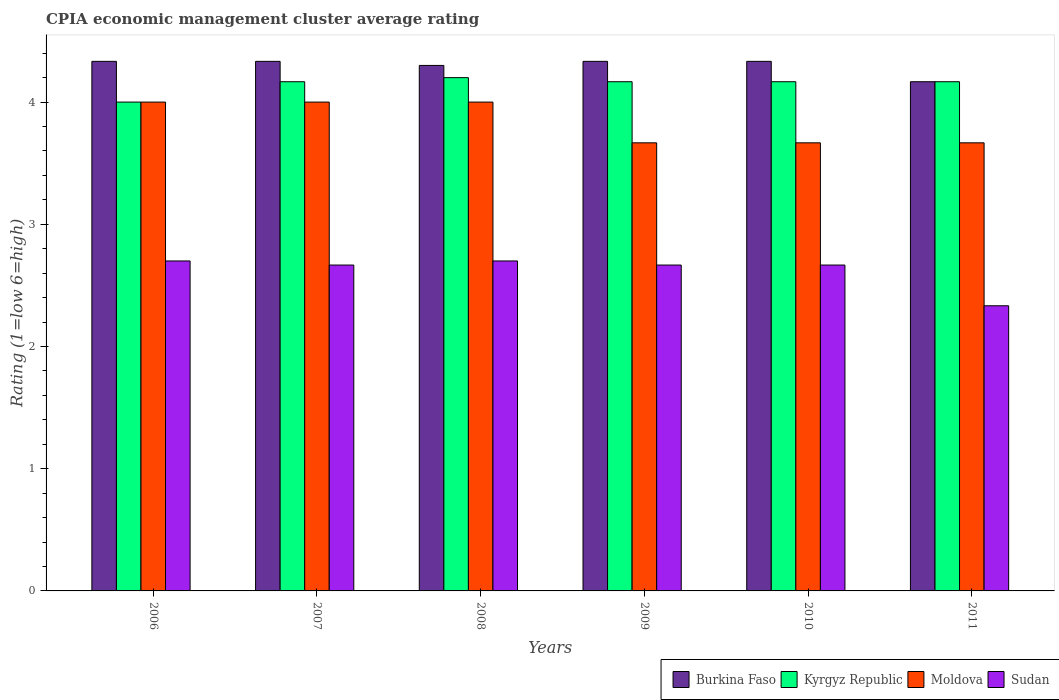How many different coloured bars are there?
Offer a terse response. 4. How many groups of bars are there?
Make the answer very short. 6. What is the label of the 3rd group of bars from the left?
Your answer should be very brief. 2008. Across all years, what is the maximum CPIA rating in Kyrgyz Republic?
Provide a short and direct response. 4.2. In which year was the CPIA rating in Kyrgyz Republic maximum?
Provide a short and direct response. 2008. In which year was the CPIA rating in Sudan minimum?
Keep it short and to the point. 2011. What is the total CPIA rating in Burkina Faso in the graph?
Your answer should be very brief. 25.8. What is the difference between the CPIA rating in Burkina Faso in 2008 and that in 2011?
Ensure brevity in your answer.  0.13. What is the difference between the CPIA rating in Burkina Faso in 2010 and the CPIA rating in Sudan in 2006?
Make the answer very short. 1.63. What is the average CPIA rating in Moldova per year?
Make the answer very short. 3.83. In the year 2006, what is the difference between the CPIA rating in Moldova and CPIA rating in Sudan?
Provide a succinct answer. 1.3. Is the CPIA rating in Sudan in 2006 less than that in 2007?
Ensure brevity in your answer.  No. What is the difference between the highest and the lowest CPIA rating in Burkina Faso?
Give a very brief answer. 0.17. Is it the case that in every year, the sum of the CPIA rating in Moldova and CPIA rating in Sudan is greater than the sum of CPIA rating in Kyrgyz Republic and CPIA rating in Burkina Faso?
Provide a short and direct response. Yes. What does the 2nd bar from the left in 2009 represents?
Provide a succinct answer. Kyrgyz Republic. What does the 3rd bar from the right in 2010 represents?
Provide a succinct answer. Kyrgyz Republic. Are all the bars in the graph horizontal?
Your answer should be compact. No. How many years are there in the graph?
Your response must be concise. 6. What is the difference between two consecutive major ticks on the Y-axis?
Your answer should be compact. 1. How many legend labels are there?
Your response must be concise. 4. How are the legend labels stacked?
Offer a very short reply. Horizontal. What is the title of the graph?
Your answer should be very brief. CPIA economic management cluster average rating. What is the label or title of the X-axis?
Ensure brevity in your answer.  Years. What is the Rating (1=low 6=high) of Burkina Faso in 2006?
Ensure brevity in your answer.  4.33. What is the Rating (1=low 6=high) of Kyrgyz Republic in 2006?
Offer a very short reply. 4. What is the Rating (1=low 6=high) in Moldova in 2006?
Make the answer very short. 4. What is the Rating (1=low 6=high) in Burkina Faso in 2007?
Your answer should be very brief. 4.33. What is the Rating (1=low 6=high) of Kyrgyz Republic in 2007?
Your response must be concise. 4.17. What is the Rating (1=low 6=high) in Moldova in 2007?
Provide a succinct answer. 4. What is the Rating (1=low 6=high) in Sudan in 2007?
Make the answer very short. 2.67. What is the Rating (1=low 6=high) in Kyrgyz Republic in 2008?
Give a very brief answer. 4.2. What is the Rating (1=low 6=high) of Burkina Faso in 2009?
Give a very brief answer. 4.33. What is the Rating (1=low 6=high) of Kyrgyz Republic in 2009?
Keep it short and to the point. 4.17. What is the Rating (1=low 6=high) in Moldova in 2009?
Provide a short and direct response. 3.67. What is the Rating (1=low 6=high) in Sudan in 2009?
Your answer should be very brief. 2.67. What is the Rating (1=low 6=high) in Burkina Faso in 2010?
Provide a short and direct response. 4.33. What is the Rating (1=low 6=high) of Kyrgyz Republic in 2010?
Your answer should be very brief. 4.17. What is the Rating (1=low 6=high) in Moldova in 2010?
Offer a very short reply. 3.67. What is the Rating (1=low 6=high) in Sudan in 2010?
Ensure brevity in your answer.  2.67. What is the Rating (1=low 6=high) in Burkina Faso in 2011?
Your response must be concise. 4.17. What is the Rating (1=low 6=high) in Kyrgyz Republic in 2011?
Your response must be concise. 4.17. What is the Rating (1=low 6=high) in Moldova in 2011?
Offer a terse response. 3.67. What is the Rating (1=low 6=high) of Sudan in 2011?
Make the answer very short. 2.33. Across all years, what is the maximum Rating (1=low 6=high) of Burkina Faso?
Your response must be concise. 4.33. Across all years, what is the maximum Rating (1=low 6=high) of Kyrgyz Republic?
Make the answer very short. 4.2. Across all years, what is the maximum Rating (1=low 6=high) of Moldova?
Ensure brevity in your answer.  4. Across all years, what is the maximum Rating (1=low 6=high) in Sudan?
Your answer should be compact. 2.7. Across all years, what is the minimum Rating (1=low 6=high) of Burkina Faso?
Give a very brief answer. 4.17. Across all years, what is the minimum Rating (1=low 6=high) in Moldova?
Make the answer very short. 3.67. Across all years, what is the minimum Rating (1=low 6=high) of Sudan?
Keep it short and to the point. 2.33. What is the total Rating (1=low 6=high) in Burkina Faso in the graph?
Offer a terse response. 25.8. What is the total Rating (1=low 6=high) in Kyrgyz Republic in the graph?
Your response must be concise. 24.87. What is the total Rating (1=low 6=high) in Sudan in the graph?
Your response must be concise. 15.73. What is the difference between the Rating (1=low 6=high) in Burkina Faso in 2006 and that in 2007?
Your answer should be compact. 0. What is the difference between the Rating (1=low 6=high) of Burkina Faso in 2006 and that in 2008?
Make the answer very short. 0.03. What is the difference between the Rating (1=low 6=high) of Kyrgyz Republic in 2006 and that in 2008?
Make the answer very short. -0.2. What is the difference between the Rating (1=low 6=high) of Moldova in 2006 and that in 2008?
Provide a short and direct response. 0. What is the difference between the Rating (1=low 6=high) of Kyrgyz Republic in 2006 and that in 2009?
Your response must be concise. -0.17. What is the difference between the Rating (1=low 6=high) in Moldova in 2006 and that in 2009?
Provide a succinct answer. 0.33. What is the difference between the Rating (1=low 6=high) in Moldova in 2006 and that in 2010?
Provide a short and direct response. 0.33. What is the difference between the Rating (1=low 6=high) of Sudan in 2006 and that in 2010?
Offer a very short reply. 0.03. What is the difference between the Rating (1=low 6=high) of Burkina Faso in 2006 and that in 2011?
Make the answer very short. 0.17. What is the difference between the Rating (1=low 6=high) in Sudan in 2006 and that in 2011?
Your response must be concise. 0.37. What is the difference between the Rating (1=low 6=high) in Kyrgyz Republic in 2007 and that in 2008?
Keep it short and to the point. -0.03. What is the difference between the Rating (1=low 6=high) in Moldova in 2007 and that in 2008?
Your answer should be very brief. 0. What is the difference between the Rating (1=low 6=high) of Sudan in 2007 and that in 2008?
Keep it short and to the point. -0.03. What is the difference between the Rating (1=low 6=high) of Burkina Faso in 2007 and that in 2009?
Give a very brief answer. 0. What is the difference between the Rating (1=low 6=high) of Moldova in 2007 and that in 2009?
Keep it short and to the point. 0.33. What is the difference between the Rating (1=low 6=high) in Sudan in 2007 and that in 2009?
Your answer should be very brief. 0. What is the difference between the Rating (1=low 6=high) of Burkina Faso in 2007 and that in 2011?
Provide a short and direct response. 0.17. What is the difference between the Rating (1=low 6=high) in Sudan in 2007 and that in 2011?
Offer a terse response. 0.33. What is the difference between the Rating (1=low 6=high) in Burkina Faso in 2008 and that in 2009?
Provide a succinct answer. -0.03. What is the difference between the Rating (1=low 6=high) in Moldova in 2008 and that in 2009?
Your answer should be very brief. 0.33. What is the difference between the Rating (1=low 6=high) of Burkina Faso in 2008 and that in 2010?
Offer a terse response. -0.03. What is the difference between the Rating (1=low 6=high) of Burkina Faso in 2008 and that in 2011?
Give a very brief answer. 0.13. What is the difference between the Rating (1=low 6=high) of Moldova in 2008 and that in 2011?
Your response must be concise. 0.33. What is the difference between the Rating (1=low 6=high) in Sudan in 2008 and that in 2011?
Offer a terse response. 0.37. What is the difference between the Rating (1=low 6=high) in Burkina Faso in 2009 and that in 2010?
Ensure brevity in your answer.  0. What is the difference between the Rating (1=low 6=high) in Burkina Faso in 2010 and that in 2011?
Your answer should be very brief. 0.17. What is the difference between the Rating (1=low 6=high) in Kyrgyz Republic in 2010 and that in 2011?
Provide a short and direct response. 0. What is the difference between the Rating (1=low 6=high) in Moldova in 2010 and that in 2011?
Give a very brief answer. 0. What is the difference between the Rating (1=low 6=high) of Sudan in 2010 and that in 2011?
Offer a terse response. 0.33. What is the difference between the Rating (1=low 6=high) of Burkina Faso in 2006 and the Rating (1=low 6=high) of Kyrgyz Republic in 2007?
Offer a very short reply. 0.17. What is the difference between the Rating (1=low 6=high) of Burkina Faso in 2006 and the Rating (1=low 6=high) of Sudan in 2007?
Offer a terse response. 1.67. What is the difference between the Rating (1=low 6=high) in Kyrgyz Republic in 2006 and the Rating (1=low 6=high) in Sudan in 2007?
Ensure brevity in your answer.  1.33. What is the difference between the Rating (1=low 6=high) of Moldova in 2006 and the Rating (1=low 6=high) of Sudan in 2007?
Your answer should be compact. 1.33. What is the difference between the Rating (1=low 6=high) in Burkina Faso in 2006 and the Rating (1=low 6=high) in Kyrgyz Republic in 2008?
Your response must be concise. 0.13. What is the difference between the Rating (1=low 6=high) of Burkina Faso in 2006 and the Rating (1=low 6=high) of Sudan in 2008?
Provide a short and direct response. 1.63. What is the difference between the Rating (1=low 6=high) of Kyrgyz Republic in 2006 and the Rating (1=low 6=high) of Moldova in 2008?
Provide a short and direct response. 0. What is the difference between the Rating (1=low 6=high) in Kyrgyz Republic in 2006 and the Rating (1=low 6=high) in Sudan in 2008?
Offer a terse response. 1.3. What is the difference between the Rating (1=low 6=high) of Moldova in 2006 and the Rating (1=low 6=high) of Sudan in 2008?
Offer a very short reply. 1.3. What is the difference between the Rating (1=low 6=high) of Burkina Faso in 2006 and the Rating (1=low 6=high) of Kyrgyz Republic in 2009?
Your answer should be very brief. 0.17. What is the difference between the Rating (1=low 6=high) in Burkina Faso in 2006 and the Rating (1=low 6=high) in Sudan in 2009?
Your answer should be very brief. 1.67. What is the difference between the Rating (1=low 6=high) of Kyrgyz Republic in 2006 and the Rating (1=low 6=high) of Sudan in 2009?
Provide a short and direct response. 1.33. What is the difference between the Rating (1=low 6=high) of Kyrgyz Republic in 2006 and the Rating (1=low 6=high) of Moldova in 2010?
Provide a short and direct response. 0.33. What is the difference between the Rating (1=low 6=high) of Burkina Faso in 2006 and the Rating (1=low 6=high) of Moldova in 2011?
Ensure brevity in your answer.  0.67. What is the difference between the Rating (1=low 6=high) of Burkina Faso in 2006 and the Rating (1=low 6=high) of Sudan in 2011?
Offer a terse response. 2. What is the difference between the Rating (1=low 6=high) of Burkina Faso in 2007 and the Rating (1=low 6=high) of Kyrgyz Republic in 2008?
Offer a very short reply. 0.13. What is the difference between the Rating (1=low 6=high) in Burkina Faso in 2007 and the Rating (1=low 6=high) in Sudan in 2008?
Offer a very short reply. 1.63. What is the difference between the Rating (1=low 6=high) in Kyrgyz Republic in 2007 and the Rating (1=low 6=high) in Sudan in 2008?
Keep it short and to the point. 1.47. What is the difference between the Rating (1=low 6=high) in Burkina Faso in 2007 and the Rating (1=low 6=high) in Kyrgyz Republic in 2009?
Offer a very short reply. 0.17. What is the difference between the Rating (1=low 6=high) of Burkina Faso in 2007 and the Rating (1=low 6=high) of Sudan in 2009?
Ensure brevity in your answer.  1.67. What is the difference between the Rating (1=low 6=high) in Kyrgyz Republic in 2007 and the Rating (1=low 6=high) in Moldova in 2009?
Ensure brevity in your answer.  0.5. What is the difference between the Rating (1=low 6=high) of Kyrgyz Republic in 2007 and the Rating (1=low 6=high) of Sudan in 2009?
Give a very brief answer. 1.5. What is the difference between the Rating (1=low 6=high) in Burkina Faso in 2007 and the Rating (1=low 6=high) in Kyrgyz Republic in 2010?
Give a very brief answer. 0.17. What is the difference between the Rating (1=low 6=high) of Burkina Faso in 2007 and the Rating (1=low 6=high) of Moldova in 2010?
Offer a terse response. 0.67. What is the difference between the Rating (1=low 6=high) of Burkina Faso in 2007 and the Rating (1=low 6=high) of Sudan in 2010?
Your answer should be compact. 1.67. What is the difference between the Rating (1=low 6=high) of Kyrgyz Republic in 2007 and the Rating (1=low 6=high) of Moldova in 2010?
Ensure brevity in your answer.  0.5. What is the difference between the Rating (1=low 6=high) of Moldova in 2007 and the Rating (1=low 6=high) of Sudan in 2010?
Provide a short and direct response. 1.33. What is the difference between the Rating (1=low 6=high) in Burkina Faso in 2007 and the Rating (1=low 6=high) in Kyrgyz Republic in 2011?
Offer a very short reply. 0.17. What is the difference between the Rating (1=low 6=high) of Burkina Faso in 2007 and the Rating (1=low 6=high) of Moldova in 2011?
Offer a terse response. 0.67. What is the difference between the Rating (1=low 6=high) in Burkina Faso in 2007 and the Rating (1=low 6=high) in Sudan in 2011?
Offer a very short reply. 2. What is the difference between the Rating (1=low 6=high) of Kyrgyz Republic in 2007 and the Rating (1=low 6=high) of Moldova in 2011?
Give a very brief answer. 0.5. What is the difference between the Rating (1=low 6=high) in Kyrgyz Republic in 2007 and the Rating (1=low 6=high) in Sudan in 2011?
Your answer should be compact. 1.83. What is the difference between the Rating (1=low 6=high) of Burkina Faso in 2008 and the Rating (1=low 6=high) of Kyrgyz Republic in 2009?
Ensure brevity in your answer.  0.13. What is the difference between the Rating (1=low 6=high) of Burkina Faso in 2008 and the Rating (1=low 6=high) of Moldova in 2009?
Your response must be concise. 0.63. What is the difference between the Rating (1=low 6=high) of Burkina Faso in 2008 and the Rating (1=low 6=high) of Sudan in 2009?
Your response must be concise. 1.63. What is the difference between the Rating (1=low 6=high) of Kyrgyz Republic in 2008 and the Rating (1=low 6=high) of Moldova in 2009?
Ensure brevity in your answer.  0.53. What is the difference between the Rating (1=low 6=high) in Kyrgyz Republic in 2008 and the Rating (1=low 6=high) in Sudan in 2009?
Your answer should be very brief. 1.53. What is the difference between the Rating (1=low 6=high) in Moldova in 2008 and the Rating (1=low 6=high) in Sudan in 2009?
Ensure brevity in your answer.  1.33. What is the difference between the Rating (1=low 6=high) of Burkina Faso in 2008 and the Rating (1=low 6=high) of Kyrgyz Republic in 2010?
Your answer should be compact. 0.13. What is the difference between the Rating (1=low 6=high) of Burkina Faso in 2008 and the Rating (1=low 6=high) of Moldova in 2010?
Provide a short and direct response. 0.63. What is the difference between the Rating (1=low 6=high) in Burkina Faso in 2008 and the Rating (1=low 6=high) in Sudan in 2010?
Provide a short and direct response. 1.63. What is the difference between the Rating (1=low 6=high) of Kyrgyz Republic in 2008 and the Rating (1=low 6=high) of Moldova in 2010?
Make the answer very short. 0.53. What is the difference between the Rating (1=low 6=high) in Kyrgyz Republic in 2008 and the Rating (1=low 6=high) in Sudan in 2010?
Your response must be concise. 1.53. What is the difference between the Rating (1=low 6=high) in Moldova in 2008 and the Rating (1=low 6=high) in Sudan in 2010?
Offer a very short reply. 1.33. What is the difference between the Rating (1=low 6=high) in Burkina Faso in 2008 and the Rating (1=low 6=high) in Kyrgyz Republic in 2011?
Your answer should be very brief. 0.13. What is the difference between the Rating (1=low 6=high) of Burkina Faso in 2008 and the Rating (1=low 6=high) of Moldova in 2011?
Keep it short and to the point. 0.63. What is the difference between the Rating (1=low 6=high) of Burkina Faso in 2008 and the Rating (1=low 6=high) of Sudan in 2011?
Your answer should be very brief. 1.97. What is the difference between the Rating (1=low 6=high) in Kyrgyz Republic in 2008 and the Rating (1=low 6=high) in Moldova in 2011?
Your response must be concise. 0.53. What is the difference between the Rating (1=low 6=high) in Kyrgyz Republic in 2008 and the Rating (1=low 6=high) in Sudan in 2011?
Ensure brevity in your answer.  1.87. What is the difference between the Rating (1=low 6=high) in Burkina Faso in 2009 and the Rating (1=low 6=high) in Sudan in 2010?
Keep it short and to the point. 1.67. What is the difference between the Rating (1=low 6=high) of Kyrgyz Republic in 2009 and the Rating (1=low 6=high) of Moldova in 2010?
Give a very brief answer. 0.5. What is the difference between the Rating (1=low 6=high) of Kyrgyz Republic in 2009 and the Rating (1=low 6=high) of Sudan in 2010?
Make the answer very short. 1.5. What is the difference between the Rating (1=low 6=high) in Burkina Faso in 2009 and the Rating (1=low 6=high) in Moldova in 2011?
Make the answer very short. 0.67. What is the difference between the Rating (1=low 6=high) in Kyrgyz Republic in 2009 and the Rating (1=low 6=high) in Sudan in 2011?
Your answer should be very brief. 1.83. What is the difference between the Rating (1=low 6=high) of Kyrgyz Republic in 2010 and the Rating (1=low 6=high) of Sudan in 2011?
Offer a very short reply. 1.83. What is the difference between the Rating (1=low 6=high) of Moldova in 2010 and the Rating (1=low 6=high) of Sudan in 2011?
Offer a terse response. 1.33. What is the average Rating (1=low 6=high) in Kyrgyz Republic per year?
Provide a short and direct response. 4.14. What is the average Rating (1=low 6=high) in Moldova per year?
Keep it short and to the point. 3.83. What is the average Rating (1=low 6=high) of Sudan per year?
Offer a very short reply. 2.62. In the year 2006, what is the difference between the Rating (1=low 6=high) in Burkina Faso and Rating (1=low 6=high) in Kyrgyz Republic?
Provide a short and direct response. 0.33. In the year 2006, what is the difference between the Rating (1=low 6=high) of Burkina Faso and Rating (1=low 6=high) of Sudan?
Ensure brevity in your answer.  1.63. In the year 2006, what is the difference between the Rating (1=low 6=high) of Kyrgyz Republic and Rating (1=low 6=high) of Moldova?
Provide a short and direct response. 0. In the year 2006, what is the difference between the Rating (1=low 6=high) in Kyrgyz Republic and Rating (1=low 6=high) in Sudan?
Your response must be concise. 1.3. In the year 2007, what is the difference between the Rating (1=low 6=high) of Burkina Faso and Rating (1=low 6=high) of Kyrgyz Republic?
Provide a succinct answer. 0.17. In the year 2007, what is the difference between the Rating (1=low 6=high) of Moldova and Rating (1=low 6=high) of Sudan?
Offer a very short reply. 1.33. In the year 2008, what is the difference between the Rating (1=low 6=high) of Burkina Faso and Rating (1=low 6=high) of Kyrgyz Republic?
Provide a succinct answer. 0.1. In the year 2009, what is the difference between the Rating (1=low 6=high) of Burkina Faso and Rating (1=low 6=high) of Kyrgyz Republic?
Your answer should be very brief. 0.17. In the year 2009, what is the difference between the Rating (1=low 6=high) in Burkina Faso and Rating (1=low 6=high) in Moldova?
Make the answer very short. 0.67. In the year 2009, what is the difference between the Rating (1=low 6=high) of Burkina Faso and Rating (1=low 6=high) of Sudan?
Offer a terse response. 1.67. In the year 2009, what is the difference between the Rating (1=low 6=high) in Kyrgyz Republic and Rating (1=low 6=high) in Moldova?
Your response must be concise. 0.5. In the year 2009, what is the difference between the Rating (1=low 6=high) in Kyrgyz Republic and Rating (1=low 6=high) in Sudan?
Ensure brevity in your answer.  1.5. In the year 2009, what is the difference between the Rating (1=low 6=high) in Moldova and Rating (1=low 6=high) in Sudan?
Your response must be concise. 1. In the year 2010, what is the difference between the Rating (1=low 6=high) in Burkina Faso and Rating (1=low 6=high) in Kyrgyz Republic?
Offer a terse response. 0.17. In the year 2010, what is the difference between the Rating (1=low 6=high) in Kyrgyz Republic and Rating (1=low 6=high) in Sudan?
Offer a terse response. 1.5. In the year 2010, what is the difference between the Rating (1=low 6=high) of Moldova and Rating (1=low 6=high) of Sudan?
Keep it short and to the point. 1. In the year 2011, what is the difference between the Rating (1=low 6=high) of Burkina Faso and Rating (1=low 6=high) of Kyrgyz Republic?
Ensure brevity in your answer.  0. In the year 2011, what is the difference between the Rating (1=low 6=high) in Burkina Faso and Rating (1=low 6=high) in Sudan?
Your response must be concise. 1.83. In the year 2011, what is the difference between the Rating (1=low 6=high) in Kyrgyz Republic and Rating (1=low 6=high) in Moldova?
Provide a succinct answer. 0.5. In the year 2011, what is the difference between the Rating (1=low 6=high) in Kyrgyz Republic and Rating (1=low 6=high) in Sudan?
Provide a succinct answer. 1.83. What is the ratio of the Rating (1=low 6=high) of Kyrgyz Republic in 2006 to that in 2007?
Ensure brevity in your answer.  0.96. What is the ratio of the Rating (1=low 6=high) in Sudan in 2006 to that in 2007?
Give a very brief answer. 1.01. What is the ratio of the Rating (1=low 6=high) in Kyrgyz Republic in 2006 to that in 2008?
Offer a terse response. 0.95. What is the ratio of the Rating (1=low 6=high) in Moldova in 2006 to that in 2008?
Offer a very short reply. 1. What is the ratio of the Rating (1=low 6=high) in Sudan in 2006 to that in 2008?
Your answer should be very brief. 1. What is the ratio of the Rating (1=low 6=high) in Burkina Faso in 2006 to that in 2009?
Offer a very short reply. 1. What is the ratio of the Rating (1=low 6=high) in Sudan in 2006 to that in 2009?
Give a very brief answer. 1.01. What is the ratio of the Rating (1=low 6=high) in Moldova in 2006 to that in 2010?
Provide a succinct answer. 1.09. What is the ratio of the Rating (1=low 6=high) of Sudan in 2006 to that in 2010?
Make the answer very short. 1.01. What is the ratio of the Rating (1=low 6=high) in Kyrgyz Republic in 2006 to that in 2011?
Give a very brief answer. 0.96. What is the ratio of the Rating (1=low 6=high) in Moldova in 2006 to that in 2011?
Provide a short and direct response. 1.09. What is the ratio of the Rating (1=low 6=high) of Sudan in 2006 to that in 2011?
Your answer should be very brief. 1.16. What is the ratio of the Rating (1=low 6=high) of Burkina Faso in 2007 to that in 2008?
Your response must be concise. 1.01. What is the ratio of the Rating (1=low 6=high) of Moldova in 2007 to that in 2008?
Provide a succinct answer. 1. What is the ratio of the Rating (1=low 6=high) in Sudan in 2007 to that in 2008?
Make the answer very short. 0.99. What is the ratio of the Rating (1=low 6=high) in Burkina Faso in 2007 to that in 2009?
Keep it short and to the point. 1. What is the ratio of the Rating (1=low 6=high) in Burkina Faso in 2007 to that in 2010?
Give a very brief answer. 1. What is the ratio of the Rating (1=low 6=high) of Moldova in 2007 to that in 2010?
Your answer should be compact. 1.09. What is the ratio of the Rating (1=low 6=high) of Sudan in 2007 to that in 2010?
Offer a terse response. 1. What is the ratio of the Rating (1=low 6=high) of Kyrgyz Republic in 2007 to that in 2011?
Give a very brief answer. 1. What is the ratio of the Rating (1=low 6=high) in Moldova in 2007 to that in 2011?
Keep it short and to the point. 1.09. What is the ratio of the Rating (1=low 6=high) of Moldova in 2008 to that in 2009?
Offer a terse response. 1.09. What is the ratio of the Rating (1=low 6=high) of Sudan in 2008 to that in 2009?
Your response must be concise. 1.01. What is the ratio of the Rating (1=low 6=high) of Burkina Faso in 2008 to that in 2010?
Keep it short and to the point. 0.99. What is the ratio of the Rating (1=low 6=high) in Moldova in 2008 to that in 2010?
Make the answer very short. 1.09. What is the ratio of the Rating (1=low 6=high) in Sudan in 2008 to that in 2010?
Provide a short and direct response. 1.01. What is the ratio of the Rating (1=low 6=high) of Burkina Faso in 2008 to that in 2011?
Offer a terse response. 1.03. What is the ratio of the Rating (1=low 6=high) in Moldova in 2008 to that in 2011?
Ensure brevity in your answer.  1.09. What is the ratio of the Rating (1=low 6=high) of Sudan in 2008 to that in 2011?
Provide a succinct answer. 1.16. What is the ratio of the Rating (1=low 6=high) of Burkina Faso in 2009 to that in 2010?
Provide a short and direct response. 1. What is the ratio of the Rating (1=low 6=high) of Sudan in 2009 to that in 2010?
Your response must be concise. 1. What is the ratio of the Rating (1=low 6=high) of Sudan in 2009 to that in 2011?
Give a very brief answer. 1.14. What is the ratio of the Rating (1=low 6=high) of Burkina Faso in 2010 to that in 2011?
Ensure brevity in your answer.  1.04. What is the ratio of the Rating (1=low 6=high) in Sudan in 2010 to that in 2011?
Give a very brief answer. 1.14. What is the difference between the highest and the second highest Rating (1=low 6=high) in Burkina Faso?
Your answer should be compact. 0. What is the difference between the highest and the second highest Rating (1=low 6=high) in Moldova?
Your answer should be very brief. 0. What is the difference between the highest and the second highest Rating (1=low 6=high) of Sudan?
Give a very brief answer. 0. What is the difference between the highest and the lowest Rating (1=low 6=high) in Burkina Faso?
Give a very brief answer. 0.17. What is the difference between the highest and the lowest Rating (1=low 6=high) in Kyrgyz Republic?
Provide a short and direct response. 0.2. What is the difference between the highest and the lowest Rating (1=low 6=high) in Moldova?
Ensure brevity in your answer.  0.33. What is the difference between the highest and the lowest Rating (1=low 6=high) in Sudan?
Keep it short and to the point. 0.37. 